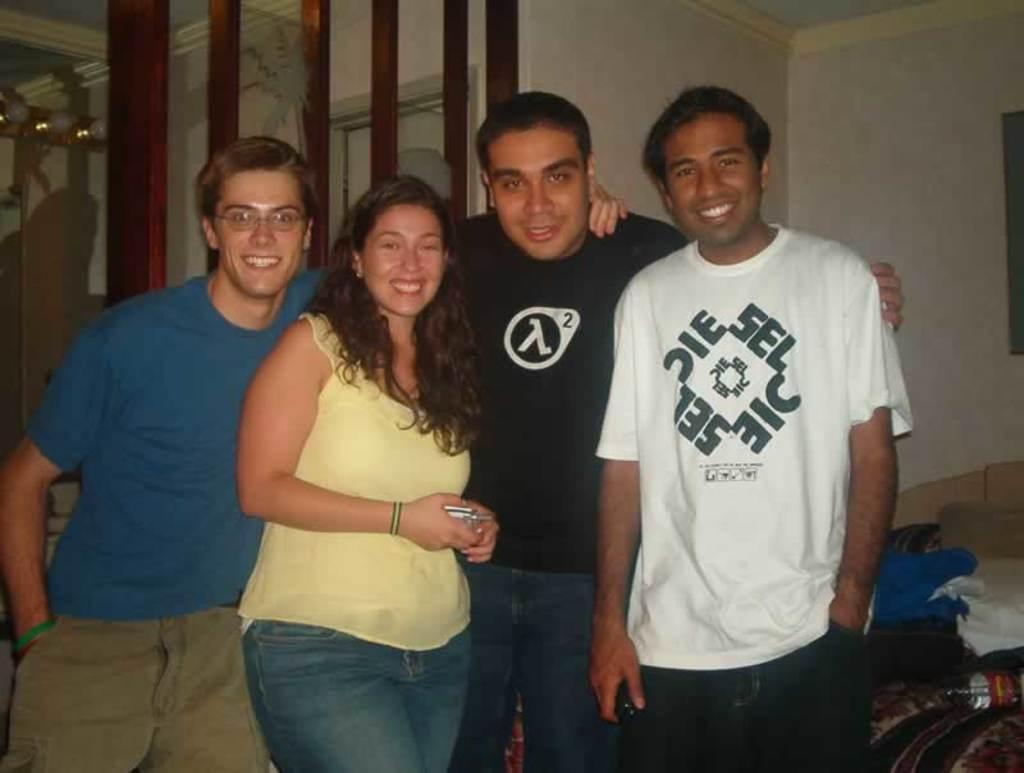How would you summarize this image in a sentence or two? In this image there are three men and a woman giving pose for a photograph, in the background there is a wall and a wooden frames. 